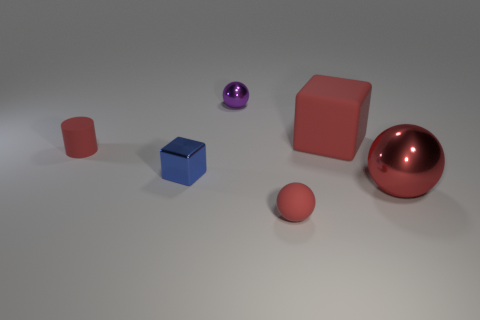Add 3 red rubber cylinders. How many objects exist? 9 Subtract all blocks. How many objects are left? 4 Subtract 0 cyan spheres. How many objects are left? 6 Subtract all cyan shiny balls. Subtract all large red balls. How many objects are left? 5 Add 6 small red matte spheres. How many small red matte spheres are left? 7 Add 2 large metal spheres. How many large metal spheres exist? 3 